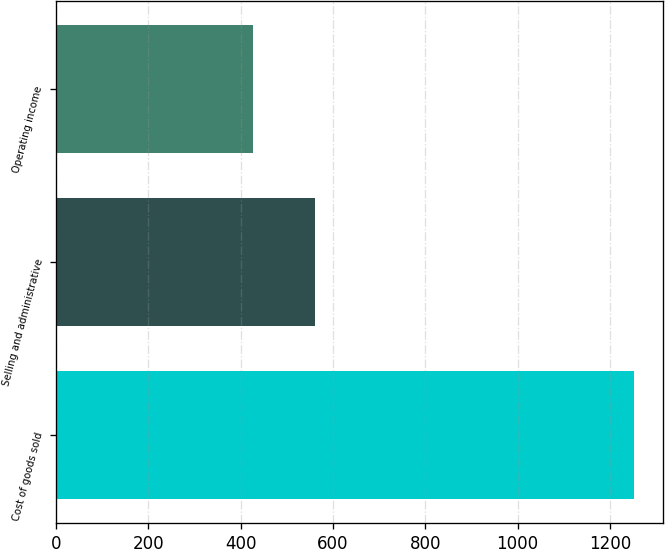Convert chart to OTSL. <chart><loc_0><loc_0><loc_500><loc_500><bar_chart><fcel>Cost of goods sold<fcel>Selling and administrative<fcel>Operating income<nl><fcel>1252.7<fcel>559.8<fcel>425.5<nl></chart> 